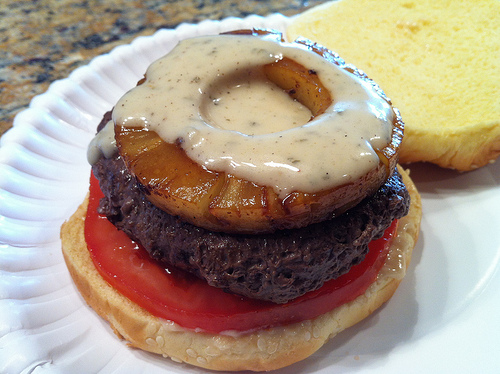<image>
Is the grilled pineapple next to the bun? Yes. The grilled pineapple is positioned adjacent to the bun, located nearby in the same general area. Where is the donut in relation to the bun? Is it under the bun? No. The donut is not positioned under the bun. The vertical relationship between these objects is different. 